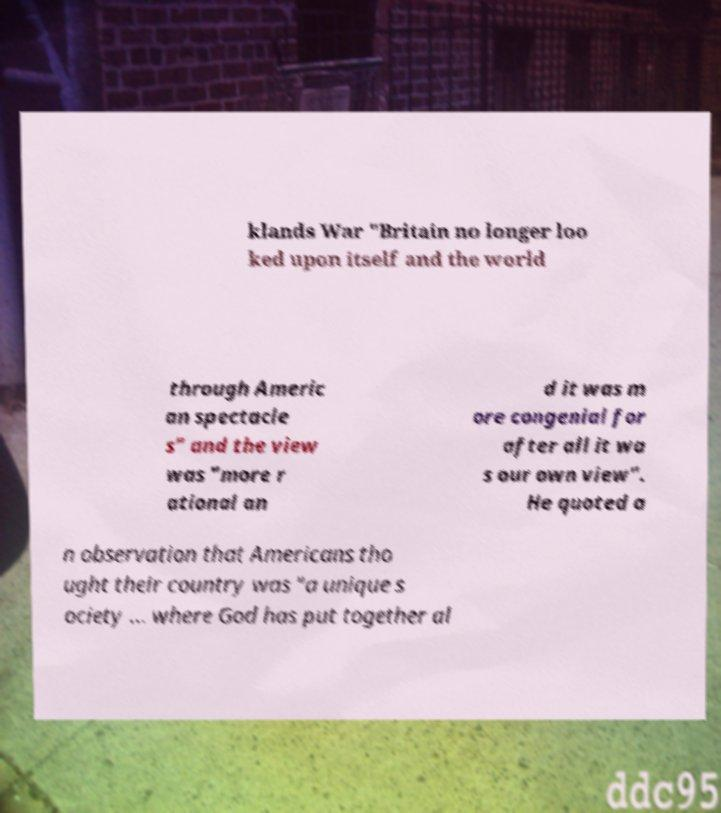I need the written content from this picture converted into text. Can you do that? klands War "Britain no longer loo ked upon itself and the world through Americ an spectacle s" and the view was "more r ational an d it was m ore congenial for after all it wa s our own view". He quoted a n observation that Americans tho ught their country was "a unique s ociety ... where God has put together al 